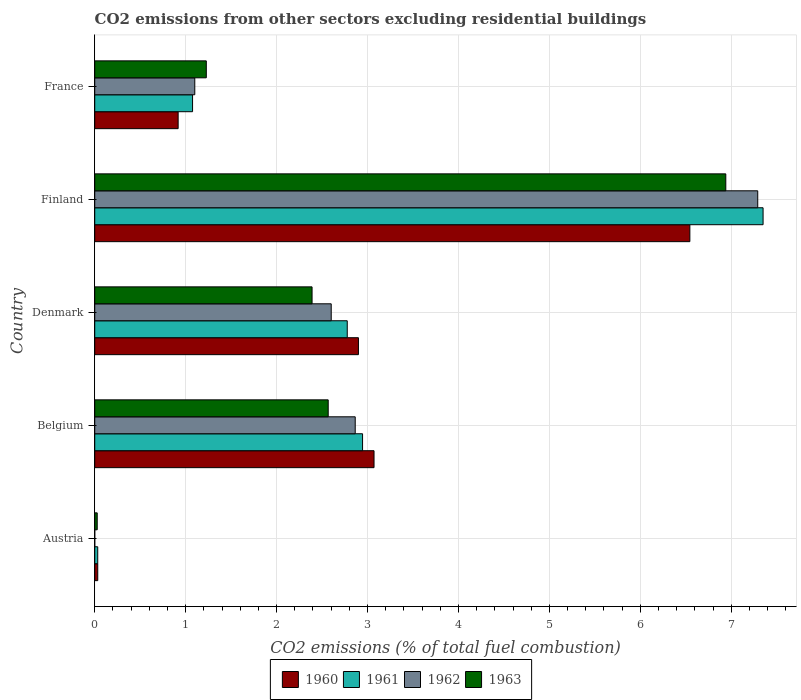How many different coloured bars are there?
Make the answer very short. 4. How many groups of bars are there?
Provide a succinct answer. 5. Are the number of bars per tick equal to the number of legend labels?
Ensure brevity in your answer.  No. How many bars are there on the 5th tick from the bottom?
Your answer should be compact. 4. In how many cases, is the number of bars for a given country not equal to the number of legend labels?
Provide a succinct answer. 1. What is the total CO2 emitted in 1963 in France?
Ensure brevity in your answer.  1.23. Across all countries, what is the maximum total CO2 emitted in 1963?
Offer a terse response. 6.94. Across all countries, what is the minimum total CO2 emitted in 1963?
Provide a succinct answer. 0.03. What is the total total CO2 emitted in 1960 in the graph?
Ensure brevity in your answer.  13.47. What is the difference between the total CO2 emitted in 1963 in Austria and that in France?
Ensure brevity in your answer.  -1.2. What is the difference between the total CO2 emitted in 1960 in Austria and the total CO2 emitted in 1962 in France?
Ensure brevity in your answer.  -1.07. What is the average total CO2 emitted in 1960 per country?
Ensure brevity in your answer.  2.69. What is the difference between the total CO2 emitted in 1960 and total CO2 emitted in 1962 in France?
Provide a succinct answer. -0.18. In how many countries, is the total CO2 emitted in 1961 greater than 7.2 ?
Offer a very short reply. 1. What is the ratio of the total CO2 emitted in 1961 in Finland to that in France?
Give a very brief answer. 6.83. Is the difference between the total CO2 emitted in 1960 in Belgium and France greater than the difference between the total CO2 emitted in 1962 in Belgium and France?
Offer a terse response. Yes. What is the difference between the highest and the second highest total CO2 emitted in 1962?
Provide a succinct answer. 4.43. What is the difference between the highest and the lowest total CO2 emitted in 1960?
Your answer should be compact. 6.51. In how many countries, is the total CO2 emitted in 1962 greater than the average total CO2 emitted in 1962 taken over all countries?
Provide a succinct answer. 2. Is the sum of the total CO2 emitted in 1961 in Denmark and France greater than the maximum total CO2 emitted in 1963 across all countries?
Your answer should be compact. No. Is it the case that in every country, the sum of the total CO2 emitted in 1962 and total CO2 emitted in 1961 is greater than the sum of total CO2 emitted in 1963 and total CO2 emitted in 1960?
Offer a very short reply. No. Is it the case that in every country, the sum of the total CO2 emitted in 1963 and total CO2 emitted in 1960 is greater than the total CO2 emitted in 1961?
Offer a very short reply. Yes. What is the difference between two consecutive major ticks on the X-axis?
Provide a short and direct response. 1. Are the values on the major ticks of X-axis written in scientific E-notation?
Provide a succinct answer. No. Does the graph contain grids?
Your answer should be compact. Yes. Where does the legend appear in the graph?
Give a very brief answer. Bottom center. What is the title of the graph?
Ensure brevity in your answer.  CO2 emissions from other sectors excluding residential buildings. Does "1982" appear as one of the legend labels in the graph?
Give a very brief answer. No. What is the label or title of the X-axis?
Provide a succinct answer. CO2 emissions (% of total fuel combustion). What is the label or title of the Y-axis?
Give a very brief answer. Country. What is the CO2 emissions (% of total fuel combustion) in 1960 in Austria?
Your answer should be compact. 0.03. What is the CO2 emissions (% of total fuel combustion) of 1961 in Austria?
Give a very brief answer. 0.03. What is the CO2 emissions (% of total fuel combustion) of 1962 in Austria?
Give a very brief answer. 0. What is the CO2 emissions (% of total fuel combustion) in 1963 in Austria?
Your answer should be very brief. 0.03. What is the CO2 emissions (% of total fuel combustion) in 1960 in Belgium?
Keep it short and to the point. 3.07. What is the CO2 emissions (% of total fuel combustion) of 1961 in Belgium?
Ensure brevity in your answer.  2.95. What is the CO2 emissions (% of total fuel combustion) in 1962 in Belgium?
Your answer should be very brief. 2.86. What is the CO2 emissions (% of total fuel combustion) in 1963 in Belgium?
Make the answer very short. 2.57. What is the CO2 emissions (% of total fuel combustion) in 1960 in Denmark?
Ensure brevity in your answer.  2.9. What is the CO2 emissions (% of total fuel combustion) in 1961 in Denmark?
Your answer should be compact. 2.78. What is the CO2 emissions (% of total fuel combustion) of 1962 in Denmark?
Keep it short and to the point. 2.6. What is the CO2 emissions (% of total fuel combustion) in 1963 in Denmark?
Ensure brevity in your answer.  2.39. What is the CO2 emissions (% of total fuel combustion) in 1960 in Finland?
Give a very brief answer. 6.54. What is the CO2 emissions (% of total fuel combustion) of 1961 in Finland?
Your answer should be compact. 7.35. What is the CO2 emissions (% of total fuel combustion) of 1962 in Finland?
Your answer should be very brief. 7.29. What is the CO2 emissions (% of total fuel combustion) in 1963 in Finland?
Give a very brief answer. 6.94. What is the CO2 emissions (% of total fuel combustion) in 1960 in France?
Provide a short and direct response. 0.92. What is the CO2 emissions (% of total fuel combustion) of 1961 in France?
Give a very brief answer. 1.08. What is the CO2 emissions (% of total fuel combustion) of 1962 in France?
Provide a succinct answer. 1.1. What is the CO2 emissions (% of total fuel combustion) of 1963 in France?
Ensure brevity in your answer.  1.23. Across all countries, what is the maximum CO2 emissions (% of total fuel combustion) of 1960?
Your response must be concise. 6.54. Across all countries, what is the maximum CO2 emissions (% of total fuel combustion) in 1961?
Your answer should be compact. 7.35. Across all countries, what is the maximum CO2 emissions (% of total fuel combustion) in 1962?
Offer a terse response. 7.29. Across all countries, what is the maximum CO2 emissions (% of total fuel combustion) in 1963?
Keep it short and to the point. 6.94. Across all countries, what is the minimum CO2 emissions (% of total fuel combustion) in 1960?
Make the answer very short. 0.03. Across all countries, what is the minimum CO2 emissions (% of total fuel combustion) of 1961?
Keep it short and to the point. 0.03. Across all countries, what is the minimum CO2 emissions (% of total fuel combustion) in 1963?
Offer a very short reply. 0.03. What is the total CO2 emissions (% of total fuel combustion) of 1960 in the graph?
Make the answer very short. 13.47. What is the total CO2 emissions (% of total fuel combustion) in 1961 in the graph?
Your answer should be compact. 14.18. What is the total CO2 emissions (% of total fuel combustion) in 1962 in the graph?
Keep it short and to the point. 13.86. What is the total CO2 emissions (% of total fuel combustion) in 1963 in the graph?
Your response must be concise. 13.15. What is the difference between the CO2 emissions (% of total fuel combustion) of 1960 in Austria and that in Belgium?
Provide a succinct answer. -3.04. What is the difference between the CO2 emissions (% of total fuel combustion) of 1961 in Austria and that in Belgium?
Keep it short and to the point. -2.91. What is the difference between the CO2 emissions (% of total fuel combustion) of 1963 in Austria and that in Belgium?
Provide a succinct answer. -2.54. What is the difference between the CO2 emissions (% of total fuel combustion) in 1960 in Austria and that in Denmark?
Give a very brief answer. -2.87. What is the difference between the CO2 emissions (% of total fuel combustion) in 1961 in Austria and that in Denmark?
Your answer should be very brief. -2.74. What is the difference between the CO2 emissions (% of total fuel combustion) of 1963 in Austria and that in Denmark?
Give a very brief answer. -2.36. What is the difference between the CO2 emissions (% of total fuel combustion) of 1960 in Austria and that in Finland?
Provide a succinct answer. -6.51. What is the difference between the CO2 emissions (% of total fuel combustion) in 1961 in Austria and that in Finland?
Keep it short and to the point. -7.32. What is the difference between the CO2 emissions (% of total fuel combustion) in 1963 in Austria and that in Finland?
Keep it short and to the point. -6.91. What is the difference between the CO2 emissions (% of total fuel combustion) of 1960 in Austria and that in France?
Make the answer very short. -0.88. What is the difference between the CO2 emissions (% of total fuel combustion) of 1961 in Austria and that in France?
Your answer should be very brief. -1.04. What is the difference between the CO2 emissions (% of total fuel combustion) in 1963 in Austria and that in France?
Offer a very short reply. -1.2. What is the difference between the CO2 emissions (% of total fuel combustion) of 1960 in Belgium and that in Denmark?
Offer a very short reply. 0.17. What is the difference between the CO2 emissions (% of total fuel combustion) in 1961 in Belgium and that in Denmark?
Ensure brevity in your answer.  0.17. What is the difference between the CO2 emissions (% of total fuel combustion) in 1962 in Belgium and that in Denmark?
Provide a succinct answer. 0.26. What is the difference between the CO2 emissions (% of total fuel combustion) in 1963 in Belgium and that in Denmark?
Give a very brief answer. 0.18. What is the difference between the CO2 emissions (% of total fuel combustion) of 1960 in Belgium and that in Finland?
Offer a terse response. -3.47. What is the difference between the CO2 emissions (% of total fuel combustion) in 1961 in Belgium and that in Finland?
Offer a terse response. -4.4. What is the difference between the CO2 emissions (% of total fuel combustion) of 1962 in Belgium and that in Finland?
Make the answer very short. -4.43. What is the difference between the CO2 emissions (% of total fuel combustion) in 1963 in Belgium and that in Finland?
Keep it short and to the point. -4.37. What is the difference between the CO2 emissions (% of total fuel combustion) in 1960 in Belgium and that in France?
Keep it short and to the point. 2.15. What is the difference between the CO2 emissions (% of total fuel combustion) of 1961 in Belgium and that in France?
Your response must be concise. 1.87. What is the difference between the CO2 emissions (% of total fuel combustion) of 1962 in Belgium and that in France?
Your answer should be compact. 1.76. What is the difference between the CO2 emissions (% of total fuel combustion) of 1963 in Belgium and that in France?
Provide a short and direct response. 1.34. What is the difference between the CO2 emissions (% of total fuel combustion) in 1960 in Denmark and that in Finland?
Give a very brief answer. -3.64. What is the difference between the CO2 emissions (% of total fuel combustion) in 1961 in Denmark and that in Finland?
Your answer should be compact. -4.57. What is the difference between the CO2 emissions (% of total fuel combustion) of 1962 in Denmark and that in Finland?
Keep it short and to the point. -4.69. What is the difference between the CO2 emissions (% of total fuel combustion) in 1963 in Denmark and that in Finland?
Give a very brief answer. -4.55. What is the difference between the CO2 emissions (% of total fuel combustion) in 1960 in Denmark and that in France?
Your response must be concise. 1.98. What is the difference between the CO2 emissions (% of total fuel combustion) in 1961 in Denmark and that in France?
Provide a succinct answer. 1.7. What is the difference between the CO2 emissions (% of total fuel combustion) in 1962 in Denmark and that in France?
Keep it short and to the point. 1.5. What is the difference between the CO2 emissions (% of total fuel combustion) of 1963 in Denmark and that in France?
Your answer should be compact. 1.16. What is the difference between the CO2 emissions (% of total fuel combustion) in 1960 in Finland and that in France?
Make the answer very short. 5.63. What is the difference between the CO2 emissions (% of total fuel combustion) of 1961 in Finland and that in France?
Your answer should be very brief. 6.27. What is the difference between the CO2 emissions (% of total fuel combustion) in 1962 in Finland and that in France?
Give a very brief answer. 6.19. What is the difference between the CO2 emissions (% of total fuel combustion) in 1963 in Finland and that in France?
Your answer should be very brief. 5.71. What is the difference between the CO2 emissions (% of total fuel combustion) in 1960 in Austria and the CO2 emissions (% of total fuel combustion) in 1961 in Belgium?
Give a very brief answer. -2.91. What is the difference between the CO2 emissions (% of total fuel combustion) in 1960 in Austria and the CO2 emissions (% of total fuel combustion) in 1962 in Belgium?
Offer a very short reply. -2.83. What is the difference between the CO2 emissions (% of total fuel combustion) of 1960 in Austria and the CO2 emissions (% of total fuel combustion) of 1963 in Belgium?
Give a very brief answer. -2.53. What is the difference between the CO2 emissions (% of total fuel combustion) of 1961 in Austria and the CO2 emissions (% of total fuel combustion) of 1962 in Belgium?
Give a very brief answer. -2.83. What is the difference between the CO2 emissions (% of total fuel combustion) of 1961 in Austria and the CO2 emissions (% of total fuel combustion) of 1963 in Belgium?
Keep it short and to the point. -2.53. What is the difference between the CO2 emissions (% of total fuel combustion) of 1960 in Austria and the CO2 emissions (% of total fuel combustion) of 1961 in Denmark?
Offer a terse response. -2.74. What is the difference between the CO2 emissions (% of total fuel combustion) of 1960 in Austria and the CO2 emissions (% of total fuel combustion) of 1962 in Denmark?
Your answer should be very brief. -2.57. What is the difference between the CO2 emissions (% of total fuel combustion) in 1960 in Austria and the CO2 emissions (% of total fuel combustion) in 1963 in Denmark?
Your answer should be very brief. -2.36. What is the difference between the CO2 emissions (% of total fuel combustion) of 1961 in Austria and the CO2 emissions (% of total fuel combustion) of 1962 in Denmark?
Your answer should be very brief. -2.57. What is the difference between the CO2 emissions (% of total fuel combustion) in 1961 in Austria and the CO2 emissions (% of total fuel combustion) in 1963 in Denmark?
Offer a terse response. -2.36. What is the difference between the CO2 emissions (% of total fuel combustion) in 1960 in Austria and the CO2 emissions (% of total fuel combustion) in 1961 in Finland?
Ensure brevity in your answer.  -7.32. What is the difference between the CO2 emissions (% of total fuel combustion) in 1960 in Austria and the CO2 emissions (% of total fuel combustion) in 1962 in Finland?
Keep it short and to the point. -7.26. What is the difference between the CO2 emissions (% of total fuel combustion) in 1960 in Austria and the CO2 emissions (% of total fuel combustion) in 1963 in Finland?
Provide a short and direct response. -6.91. What is the difference between the CO2 emissions (% of total fuel combustion) in 1961 in Austria and the CO2 emissions (% of total fuel combustion) in 1962 in Finland?
Your answer should be very brief. -7.26. What is the difference between the CO2 emissions (% of total fuel combustion) of 1961 in Austria and the CO2 emissions (% of total fuel combustion) of 1963 in Finland?
Make the answer very short. -6.91. What is the difference between the CO2 emissions (% of total fuel combustion) in 1960 in Austria and the CO2 emissions (% of total fuel combustion) in 1961 in France?
Your answer should be compact. -1.04. What is the difference between the CO2 emissions (% of total fuel combustion) of 1960 in Austria and the CO2 emissions (% of total fuel combustion) of 1962 in France?
Ensure brevity in your answer.  -1.07. What is the difference between the CO2 emissions (% of total fuel combustion) in 1960 in Austria and the CO2 emissions (% of total fuel combustion) in 1963 in France?
Keep it short and to the point. -1.19. What is the difference between the CO2 emissions (% of total fuel combustion) of 1961 in Austria and the CO2 emissions (% of total fuel combustion) of 1962 in France?
Provide a short and direct response. -1.07. What is the difference between the CO2 emissions (% of total fuel combustion) of 1961 in Austria and the CO2 emissions (% of total fuel combustion) of 1963 in France?
Give a very brief answer. -1.19. What is the difference between the CO2 emissions (% of total fuel combustion) in 1960 in Belgium and the CO2 emissions (% of total fuel combustion) in 1961 in Denmark?
Provide a succinct answer. 0.29. What is the difference between the CO2 emissions (% of total fuel combustion) of 1960 in Belgium and the CO2 emissions (% of total fuel combustion) of 1962 in Denmark?
Make the answer very short. 0.47. What is the difference between the CO2 emissions (% of total fuel combustion) of 1960 in Belgium and the CO2 emissions (% of total fuel combustion) of 1963 in Denmark?
Make the answer very short. 0.68. What is the difference between the CO2 emissions (% of total fuel combustion) of 1961 in Belgium and the CO2 emissions (% of total fuel combustion) of 1962 in Denmark?
Your answer should be compact. 0.34. What is the difference between the CO2 emissions (% of total fuel combustion) in 1961 in Belgium and the CO2 emissions (% of total fuel combustion) in 1963 in Denmark?
Offer a very short reply. 0.56. What is the difference between the CO2 emissions (% of total fuel combustion) of 1962 in Belgium and the CO2 emissions (% of total fuel combustion) of 1963 in Denmark?
Your answer should be compact. 0.47. What is the difference between the CO2 emissions (% of total fuel combustion) in 1960 in Belgium and the CO2 emissions (% of total fuel combustion) in 1961 in Finland?
Your answer should be very brief. -4.28. What is the difference between the CO2 emissions (% of total fuel combustion) of 1960 in Belgium and the CO2 emissions (% of total fuel combustion) of 1962 in Finland?
Your answer should be very brief. -4.22. What is the difference between the CO2 emissions (% of total fuel combustion) of 1960 in Belgium and the CO2 emissions (% of total fuel combustion) of 1963 in Finland?
Offer a very short reply. -3.87. What is the difference between the CO2 emissions (% of total fuel combustion) in 1961 in Belgium and the CO2 emissions (% of total fuel combustion) in 1962 in Finland?
Provide a succinct answer. -4.35. What is the difference between the CO2 emissions (% of total fuel combustion) in 1961 in Belgium and the CO2 emissions (% of total fuel combustion) in 1963 in Finland?
Your answer should be very brief. -3.99. What is the difference between the CO2 emissions (% of total fuel combustion) in 1962 in Belgium and the CO2 emissions (% of total fuel combustion) in 1963 in Finland?
Keep it short and to the point. -4.08. What is the difference between the CO2 emissions (% of total fuel combustion) in 1960 in Belgium and the CO2 emissions (% of total fuel combustion) in 1961 in France?
Your response must be concise. 2. What is the difference between the CO2 emissions (% of total fuel combustion) in 1960 in Belgium and the CO2 emissions (% of total fuel combustion) in 1962 in France?
Make the answer very short. 1.97. What is the difference between the CO2 emissions (% of total fuel combustion) of 1960 in Belgium and the CO2 emissions (% of total fuel combustion) of 1963 in France?
Offer a terse response. 1.84. What is the difference between the CO2 emissions (% of total fuel combustion) in 1961 in Belgium and the CO2 emissions (% of total fuel combustion) in 1962 in France?
Offer a very short reply. 1.84. What is the difference between the CO2 emissions (% of total fuel combustion) in 1961 in Belgium and the CO2 emissions (% of total fuel combustion) in 1963 in France?
Offer a terse response. 1.72. What is the difference between the CO2 emissions (% of total fuel combustion) of 1962 in Belgium and the CO2 emissions (% of total fuel combustion) of 1963 in France?
Give a very brief answer. 1.64. What is the difference between the CO2 emissions (% of total fuel combustion) in 1960 in Denmark and the CO2 emissions (% of total fuel combustion) in 1961 in Finland?
Ensure brevity in your answer.  -4.45. What is the difference between the CO2 emissions (% of total fuel combustion) in 1960 in Denmark and the CO2 emissions (% of total fuel combustion) in 1962 in Finland?
Offer a terse response. -4.39. What is the difference between the CO2 emissions (% of total fuel combustion) of 1960 in Denmark and the CO2 emissions (% of total fuel combustion) of 1963 in Finland?
Provide a succinct answer. -4.04. What is the difference between the CO2 emissions (% of total fuel combustion) of 1961 in Denmark and the CO2 emissions (% of total fuel combustion) of 1962 in Finland?
Ensure brevity in your answer.  -4.51. What is the difference between the CO2 emissions (% of total fuel combustion) in 1961 in Denmark and the CO2 emissions (% of total fuel combustion) in 1963 in Finland?
Your answer should be very brief. -4.16. What is the difference between the CO2 emissions (% of total fuel combustion) of 1962 in Denmark and the CO2 emissions (% of total fuel combustion) of 1963 in Finland?
Your answer should be very brief. -4.34. What is the difference between the CO2 emissions (% of total fuel combustion) in 1960 in Denmark and the CO2 emissions (% of total fuel combustion) in 1961 in France?
Offer a terse response. 1.82. What is the difference between the CO2 emissions (% of total fuel combustion) of 1960 in Denmark and the CO2 emissions (% of total fuel combustion) of 1962 in France?
Make the answer very short. 1.8. What is the difference between the CO2 emissions (% of total fuel combustion) in 1960 in Denmark and the CO2 emissions (% of total fuel combustion) in 1963 in France?
Keep it short and to the point. 1.67. What is the difference between the CO2 emissions (% of total fuel combustion) of 1961 in Denmark and the CO2 emissions (% of total fuel combustion) of 1962 in France?
Provide a succinct answer. 1.68. What is the difference between the CO2 emissions (% of total fuel combustion) in 1961 in Denmark and the CO2 emissions (% of total fuel combustion) in 1963 in France?
Provide a short and direct response. 1.55. What is the difference between the CO2 emissions (% of total fuel combustion) of 1962 in Denmark and the CO2 emissions (% of total fuel combustion) of 1963 in France?
Offer a very short reply. 1.37. What is the difference between the CO2 emissions (% of total fuel combustion) of 1960 in Finland and the CO2 emissions (% of total fuel combustion) of 1961 in France?
Your answer should be very brief. 5.47. What is the difference between the CO2 emissions (% of total fuel combustion) in 1960 in Finland and the CO2 emissions (% of total fuel combustion) in 1962 in France?
Ensure brevity in your answer.  5.44. What is the difference between the CO2 emissions (% of total fuel combustion) in 1960 in Finland and the CO2 emissions (% of total fuel combustion) in 1963 in France?
Provide a short and direct response. 5.32. What is the difference between the CO2 emissions (% of total fuel combustion) of 1961 in Finland and the CO2 emissions (% of total fuel combustion) of 1962 in France?
Your answer should be compact. 6.25. What is the difference between the CO2 emissions (% of total fuel combustion) in 1961 in Finland and the CO2 emissions (% of total fuel combustion) in 1963 in France?
Make the answer very short. 6.12. What is the difference between the CO2 emissions (% of total fuel combustion) of 1962 in Finland and the CO2 emissions (% of total fuel combustion) of 1963 in France?
Provide a short and direct response. 6.06. What is the average CO2 emissions (% of total fuel combustion) of 1960 per country?
Your answer should be very brief. 2.69. What is the average CO2 emissions (% of total fuel combustion) in 1961 per country?
Your response must be concise. 2.84. What is the average CO2 emissions (% of total fuel combustion) of 1962 per country?
Provide a succinct answer. 2.77. What is the average CO2 emissions (% of total fuel combustion) of 1963 per country?
Give a very brief answer. 2.63. What is the difference between the CO2 emissions (% of total fuel combustion) in 1960 and CO2 emissions (% of total fuel combustion) in 1961 in Austria?
Your answer should be very brief. 0. What is the difference between the CO2 emissions (% of total fuel combustion) of 1960 and CO2 emissions (% of total fuel combustion) of 1963 in Austria?
Provide a short and direct response. 0.01. What is the difference between the CO2 emissions (% of total fuel combustion) of 1961 and CO2 emissions (% of total fuel combustion) of 1963 in Austria?
Give a very brief answer. 0.01. What is the difference between the CO2 emissions (% of total fuel combustion) in 1960 and CO2 emissions (% of total fuel combustion) in 1961 in Belgium?
Provide a succinct answer. 0.13. What is the difference between the CO2 emissions (% of total fuel combustion) in 1960 and CO2 emissions (% of total fuel combustion) in 1962 in Belgium?
Your answer should be compact. 0.21. What is the difference between the CO2 emissions (% of total fuel combustion) of 1960 and CO2 emissions (% of total fuel combustion) of 1963 in Belgium?
Keep it short and to the point. 0.5. What is the difference between the CO2 emissions (% of total fuel combustion) of 1961 and CO2 emissions (% of total fuel combustion) of 1962 in Belgium?
Ensure brevity in your answer.  0.08. What is the difference between the CO2 emissions (% of total fuel combustion) in 1961 and CO2 emissions (% of total fuel combustion) in 1963 in Belgium?
Your answer should be very brief. 0.38. What is the difference between the CO2 emissions (% of total fuel combustion) of 1962 and CO2 emissions (% of total fuel combustion) of 1963 in Belgium?
Your response must be concise. 0.3. What is the difference between the CO2 emissions (% of total fuel combustion) of 1960 and CO2 emissions (% of total fuel combustion) of 1961 in Denmark?
Your answer should be very brief. 0.12. What is the difference between the CO2 emissions (% of total fuel combustion) in 1960 and CO2 emissions (% of total fuel combustion) in 1962 in Denmark?
Your answer should be very brief. 0.3. What is the difference between the CO2 emissions (% of total fuel combustion) in 1960 and CO2 emissions (% of total fuel combustion) in 1963 in Denmark?
Your answer should be compact. 0.51. What is the difference between the CO2 emissions (% of total fuel combustion) in 1961 and CO2 emissions (% of total fuel combustion) in 1962 in Denmark?
Give a very brief answer. 0.18. What is the difference between the CO2 emissions (% of total fuel combustion) in 1961 and CO2 emissions (% of total fuel combustion) in 1963 in Denmark?
Give a very brief answer. 0.39. What is the difference between the CO2 emissions (% of total fuel combustion) in 1962 and CO2 emissions (% of total fuel combustion) in 1963 in Denmark?
Make the answer very short. 0.21. What is the difference between the CO2 emissions (% of total fuel combustion) of 1960 and CO2 emissions (% of total fuel combustion) of 1961 in Finland?
Your response must be concise. -0.81. What is the difference between the CO2 emissions (% of total fuel combustion) in 1960 and CO2 emissions (% of total fuel combustion) in 1962 in Finland?
Keep it short and to the point. -0.75. What is the difference between the CO2 emissions (% of total fuel combustion) in 1960 and CO2 emissions (% of total fuel combustion) in 1963 in Finland?
Ensure brevity in your answer.  -0.4. What is the difference between the CO2 emissions (% of total fuel combustion) of 1961 and CO2 emissions (% of total fuel combustion) of 1962 in Finland?
Ensure brevity in your answer.  0.06. What is the difference between the CO2 emissions (% of total fuel combustion) of 1961 and CO2 emissions (% of total fuel combustion) of 1963 in Finland?
Keep it short and to the point. 0.41. What is the difference between the CO2 emissions (% of total fuel combustion) in 1962 and CO2 emissions (% of total fuel combustion) in 1963 in Finland?
Provide a succinct answer. 0.35. What is the difference between the CO2 emissions (% of total fuel combustion) of 1960 and CO2 emissions (% of total fuel combustion) of 1961 in France?
Your answer should be very brief. -0.16. What is the difference between the CO2 emissions (% of total fuel combustion) in 1960 and CO2 emissions (% of total fuel combustion) in 1962 in France?
Your answer should be compact. -0.18. What is the difference between the CO2 emissions (% of total fuel combustion) of 1960 and CO2 emissions (% of total fuel combustion) of 1963 in France?
Give a very brief answer. -0.31. What is the difference between the CO2 emissions (% of total fuel combustion) in 1961 and CO2 emissions (% of total fuel combustion) in 1962 in France?
Your answer should be compact. -0.02. What is the difference between the CO2 emissions (% of total fuel combustion) of 1961 and CO2 emissions (% of total fuel combustion) of 1963 in France?
Make the answer very short. -0.15. What is the difference between the CO2 emissions (% of total fuel combustion) of 1962 and CO2 emissions (% of total fuel combustion) of 1963 in France?
Offer a very short reply. -0.13. What is the ratio of the CO2 emissions (% of total fuel combustion) of 1960 in Austria to that in Belgium?
Your response must be concise. 0.01. What is the ratio of the CO2 emissions (% of total fuel combustion) of 1961 in Austria to that in Belgium?
Your answer should be compact. 0.01. What is the ratio of the CO2 emissions (% of total fuel combustion) of 1963 in Austria to that in Belgium?
Your answer should be very brief. 0.01. What is the ratio of the CO2 emissions (% of total fuel combustion) of 1960 in Austria to that in Denmark?
Provide a short and direct response. 0.01. What is the ratio of the CO2 emissions (% of total fuel combustion) of 1961 in Austria to that in Denmark?
Provide a succinct answer. 0.01. What is the ratio of the CO2 emissions (% of total fuel combustion) in 1963 in Austria to that in Denmark?
Make the answer very short. 0.01. What is the ratio of the CO2 emissions (% of total fuel combustion) of 1960 in Austria to that in Finland?
Your answer should be very brief. 0.01. What is the ratio of the CO2 emissions (% of total fuel combustion) of 1961 in Austria to that in Finland?
Give a very brief answer. 0. What is the ratio of the CO2 emissions (% of total fuel combustion) in 1963 in Austria to that in Finland?
Give a very brief answer. 0. What is the ratio of the CO2 emissions (% of total fuel combustion) of 1960 in Austria to that in France?
Make the answer very short. 0.04. What is the ratio of the CO2 emissions (% of total fuel combustion) in 1961 in Austria to that in France?
Ensure brevity in your answer.  0.03. What is the ratio of the CO2 emissions (% of total fuel combustion) in 1963 in Austria to that in France?
Ensure brevity in your answer.  0.02. What is the ratio of the CO2 emissions (% of total fuel combustion) in 1960 in Belgium to that in Denmark?
Your answer should be very brief. 1.06. What is the ratio of the CO2 emissions (% of total fuel combustion) in 1961 in Belgium to that in Denmark?
Provide a succinct answer. 1.06. What is the ratio of the CO2 emissions (% of total fuel combustion) of 1962 in Belgium to that in Denmark?
Provide a short and direct response. 1.1. What is the ratio of the CO2 emissions (% of total fuel combustion) of 1963 in Belgium to that in Denmark?
Ensure brevity in your answer.  1.07. What is the ratio of the CO2 emissions (% of total fuel combustion) in 1960 in Belgium to that in Finland?
Offer a terse response. 0.47. What is the ratio of the CO2 emissions (% of total fuel combustion) in 1961 in Belgium to that in Finland?
Ensure brevity in your answer.  0.4. What is the ratio of the CO2 emissions (% of total fuel combustion) of 1962 in Belgium to that in Finland?
Offer a very short reply. 0.39. What is the ratio of the CO2 emissions (% of total fuel combustion) in 1963 in Belgium to that in Finland?
Provide a succinct answer. 0.37. What is the ratio of the CO2 emissions (% of total fuel combustion) in 1960 in Belgium to that in France?
Give a very brief answer. 3.35. What is the ratio of the CO2 emissions (% of total fuel combustion) in 1961 in Belgium to that in France?
Ensure brevity in your answer.  2.74. What is the ratio of the CO2 emissions (% of total fuel combustion) of 1962 in Belgium to that in France?
Provide a succinct answer. 2.6. What is the ratio of the CO2 emissions (% of total fuel combustion) of 1963 in Belgium to that in France?
Make the answer very short. 2.09. What is the ratio of the CO2 emissions (% of total fuel combustion) in 1960 in Denmark to that in Finland?
Offer a very short reply. 0.44. What is the ratio of the CO2 emissions (% of total fuel combustion) in 1961 in Denmark to that in Finland?
Offer a very short reply. 0.38. What is the ratio of the CO2 emissions (% of total fuel combustion) of 1962 in Denmark to that in Finland?
Give a very brief answer. 0.36. What is the ratio of the CO2 emissions (% of total fuel combustion) of 1963 in Denmark to that in Finland?
Your response must be concise. 0.34. What is the ratio of the CO2 emissions (% of total fuel combustion) in 1960 in Denmark to that in France?
Give a very brief answer. 3.16. What is the ratio of the CO2 emissions (% of total fuel combustion) of 1961 in Denmark to that in France?
Offer a very short reply. 2.58. What is the ratio of the CO2 emissions (% of total fuel combustion) of 1962 in Denmark to that in France?
Offer a terse response. 2.36. What is the ratio of the CO2 emissions (% of total fuel combustion) in 1963 in Denmark to that in France?
Give a very brief answer. 1.95. What is the ratio of the CO2 emissions (% of total fuel combustion) of 1960 in Finland to that in France?
Provide a succinct answer. 7.14. What is the ratio of the CO2 emissions (% of total fuel combustion) of 1961 in Finland to that in France?
Make the answer very short. 6.83. What is the ratio of the CO2 emissions (% of total fuel combustion) of 1962 in Finland to that in France?
Offer a terse response. 6.63. What is the ratio of the CO2 emissions (% of total fuel combustion) in 1963 in Finland to that in France?
Keep it short and to the point. 5.66. What is the difference between the highest and the second highest CO2 emissions (% of total fuel combustion) in 1960?
Keep it short and to the point. 3.47. What is the difference between the highest and the second highest CO2 emissions (% of total fuel combustion) of 1961?
Provide a succinct answer. 4.4. What is the difference between the highest and the second highest CO2 emissions (% of total fuel combustion) of 1962?
Your response must be concise. 4.43. What is the difference between the highest and the second highest CO2 emissions (% of total fuel combustion) in 1963?
Your response must be concise. 4.37. What is the difference between the highest and the lowest CO2 emissions (% of total fuel combustion) in 1960?
Give a very brief answer. 6.51. What is the difference between the highest and the lowest CO2 emissions (% of total fuel combustion) of 1961?
Provide a succinct answer. 7.32. What is the difference between the highest and the lowest CO2 emissions (% of total fuel combustion) in 1962?
Provide a succinct answer. 7.29. What is the difference between the highest and the lowest CO2 emissions (% of total fuel combustion) in 1963?
Provide a succinct answer. 6.91. 